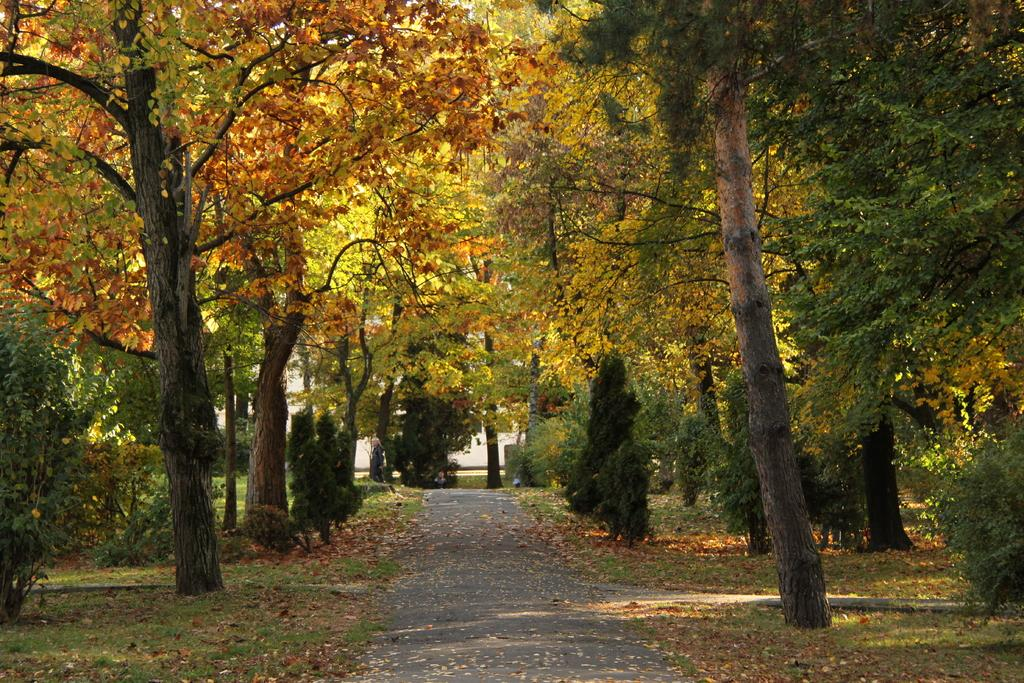What is the main feature of the image? There is a road in the image. How is the road positioned in relation to the surrounding environment? The road is situated between trees. Can you see a person in the image promoting peace with a pig? There is no person or pig present in the image; it only features a road situated between trees. 